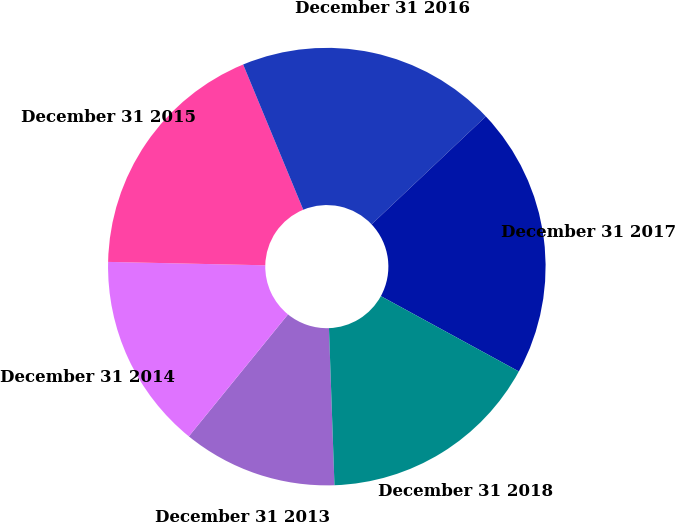Convert chart. <chart><loc_0><loc_0><loc_500><loc_500><pie_chart><fcel>December 31 2013<fcel>December 31 2014<fcel>December 31 2015<fcel>December 31 2016<fcel>December 31 2017<fcel>December 31 2018<nl><fcel>11.42%<fcel>14.48%<fcel>18.41%<fcel>19.2%<fcel>20.0%<fcel>16.49%<nl></chart> 